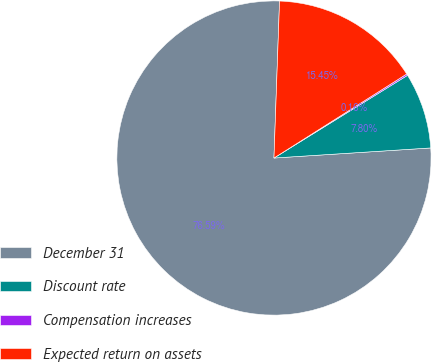Convert chart. <chart><loc_0><loc_0><loc_500><loc_500><pie_chart><fcel>December 31<fcel>Discount rate<fcel>Compensation increases<fcel>Expected return on assets<nl><fcel>76.59%<fcel>7.8%<fcel>0.16%<fcel>15.45%<nl></chart> 